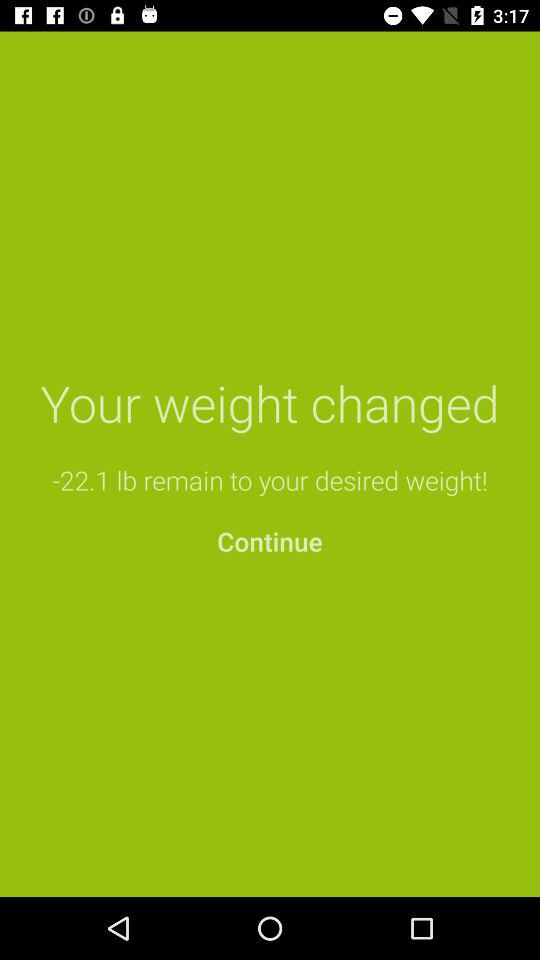What is the remaining weight? The remaining weight is -22.1 lbs. 